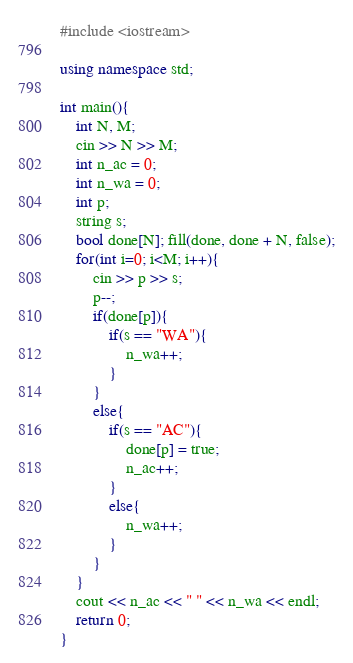<code> <loc_0><loc_0><loc_500><loc_500><_C++_>#include <iostream>

using namespace std;

int main(){
    int N, M;
    cin >> N >> M;
    int n_ac = 0;
    int n_wa = 0;
    int p;
    string s;
    bool done[N]; fill(done, done + N, false);
    for(int i=0; i<M; i++){
        cin >> p >> s;
        p--;
        if(done[p]){
            if(s == "WA"){
                n_wa++;
            }
        }
        else{
            if(s == "AC"){
                done[p] = true;
                n_ac++;
            }
            else{
                n_wa++;
            }
        }
    }   
    cout << n_ac << " " << n_wa << endl;
    return 0;
}</code> 